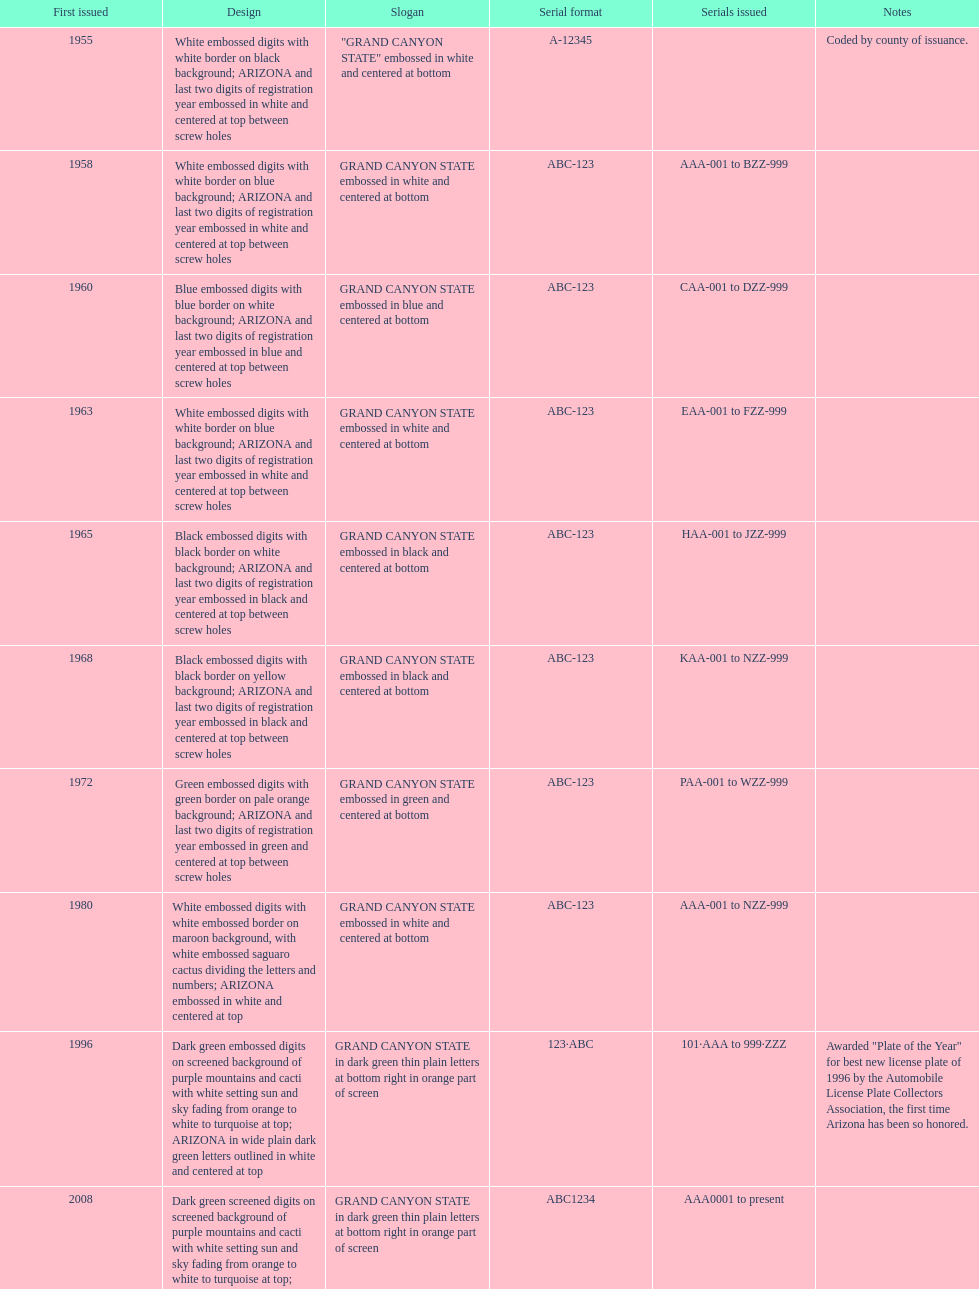Which year featured the license plate with the least characters? 1955. 